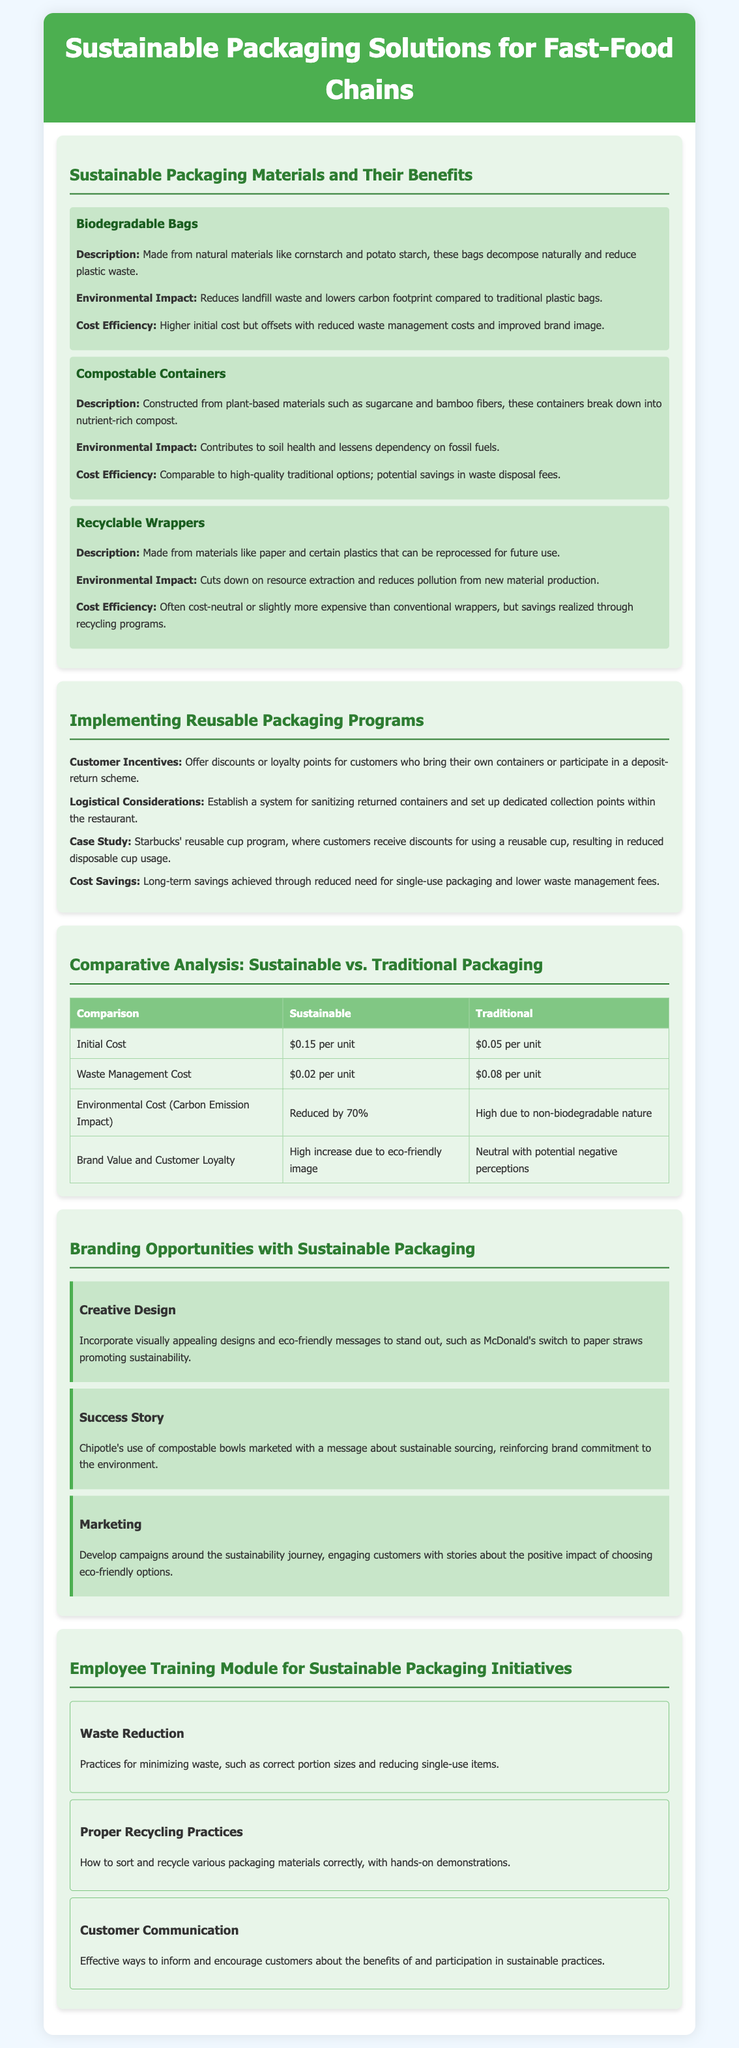What materials are biodegradable bags made from? The document states that biodegradable bags are made from natural materials like cornstarch and potato starch.
Answer: Cornstarch and potato starch What are compostable containers made from? It is mentioned that compostable containers are constructed from plant-based materials such as sugarcane and bamboo fibers.
Answer: Sugarcane and bamboo fibers How much is the initial cost per unit for sustainable packaging? The document provides that the initial cost per unit for sustainable packaging is $0.15.
Answer: $0.15 per unit What discount does Starbucks offer for using reusable cups? According to the case study in the document, Starbucks offers discounts for using a reusable cup.
Answer: Discounts What environmental impact reduction is achieved by sustainable packaging? The document notes that sustainable packaging reduces environmental impact by 70% in terms of carbon emissions.
Answer: Reduced by 70% What is a customer incentive mentioned for reusable packaging programs? The document highlights that offering discounts or loyalty points for customers participating in reusable packaging programs is an incentive.
Answer: Discounts or loyalty points Which fast-food chain uses compostable bowls to promote sustainability? The document states that Chipotle uses compostable bowls as part of their sustainability promotion.
Answer: Chipotle What is one topic covered in the employee training module? The training module covers waste reduction practices among other topics.
Answer: Waste reduction What type of environmental cost is associated with traditional packaging? The document indicates that traditional packaging has a high environmental cost due to its non-biodegradable nature.
Answer: High due to non-biodegradable nature 